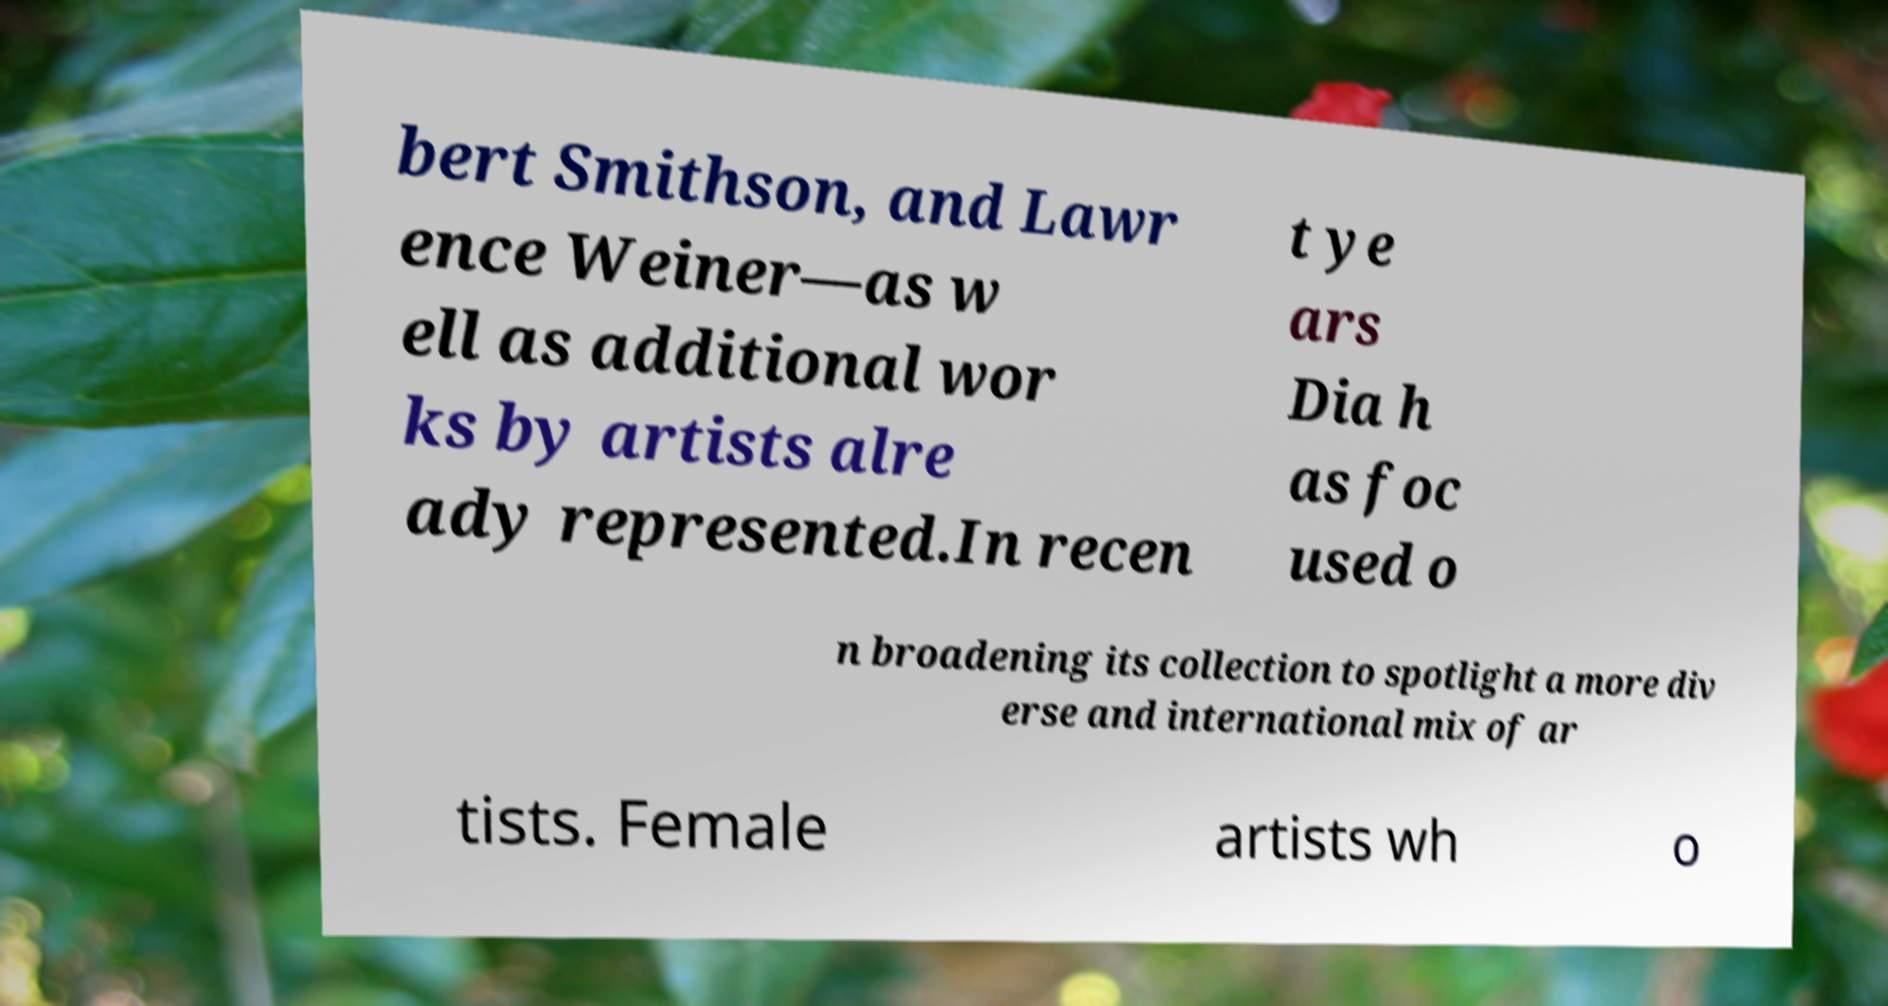There's text embedded in this image that I need extracted. Can you transcribe it verbatim? bert Smithson, and Lawr ence Weiner—as w ell as additional wor ks by artists alre ady represented.In recen t ye ars Dia h as foc used o n broadening its collection to spotlight a more div erse and international mix of ar tists. Female artists wh o 